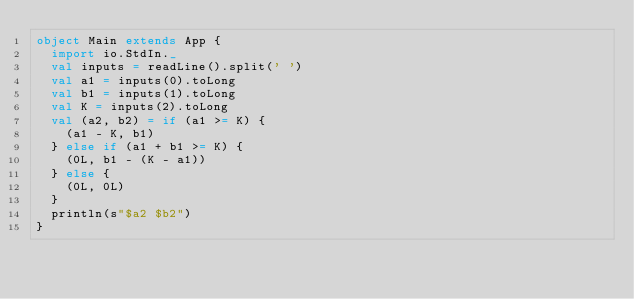Convert code to text. <code><loc_0><loc_0><loc_500><loc_500><_Scala_>object Main extends App {
  import io.StdIn._
  val inputs = readLine().split(' ')
  val a1 = inputs(0).toLong
  val b1 = inputs(1).toLong
  val K = inputs(2).toLong
  val (a2, b2) = if (a1 >= K) {
    (a1 - K, b1)
  } else if (a1 + b1 >= K) {
    (0L, b1 - (K - a1))
  } else {
    (0L, 0L)
  }
  println(s"$a2 $b2")
}
</code> 